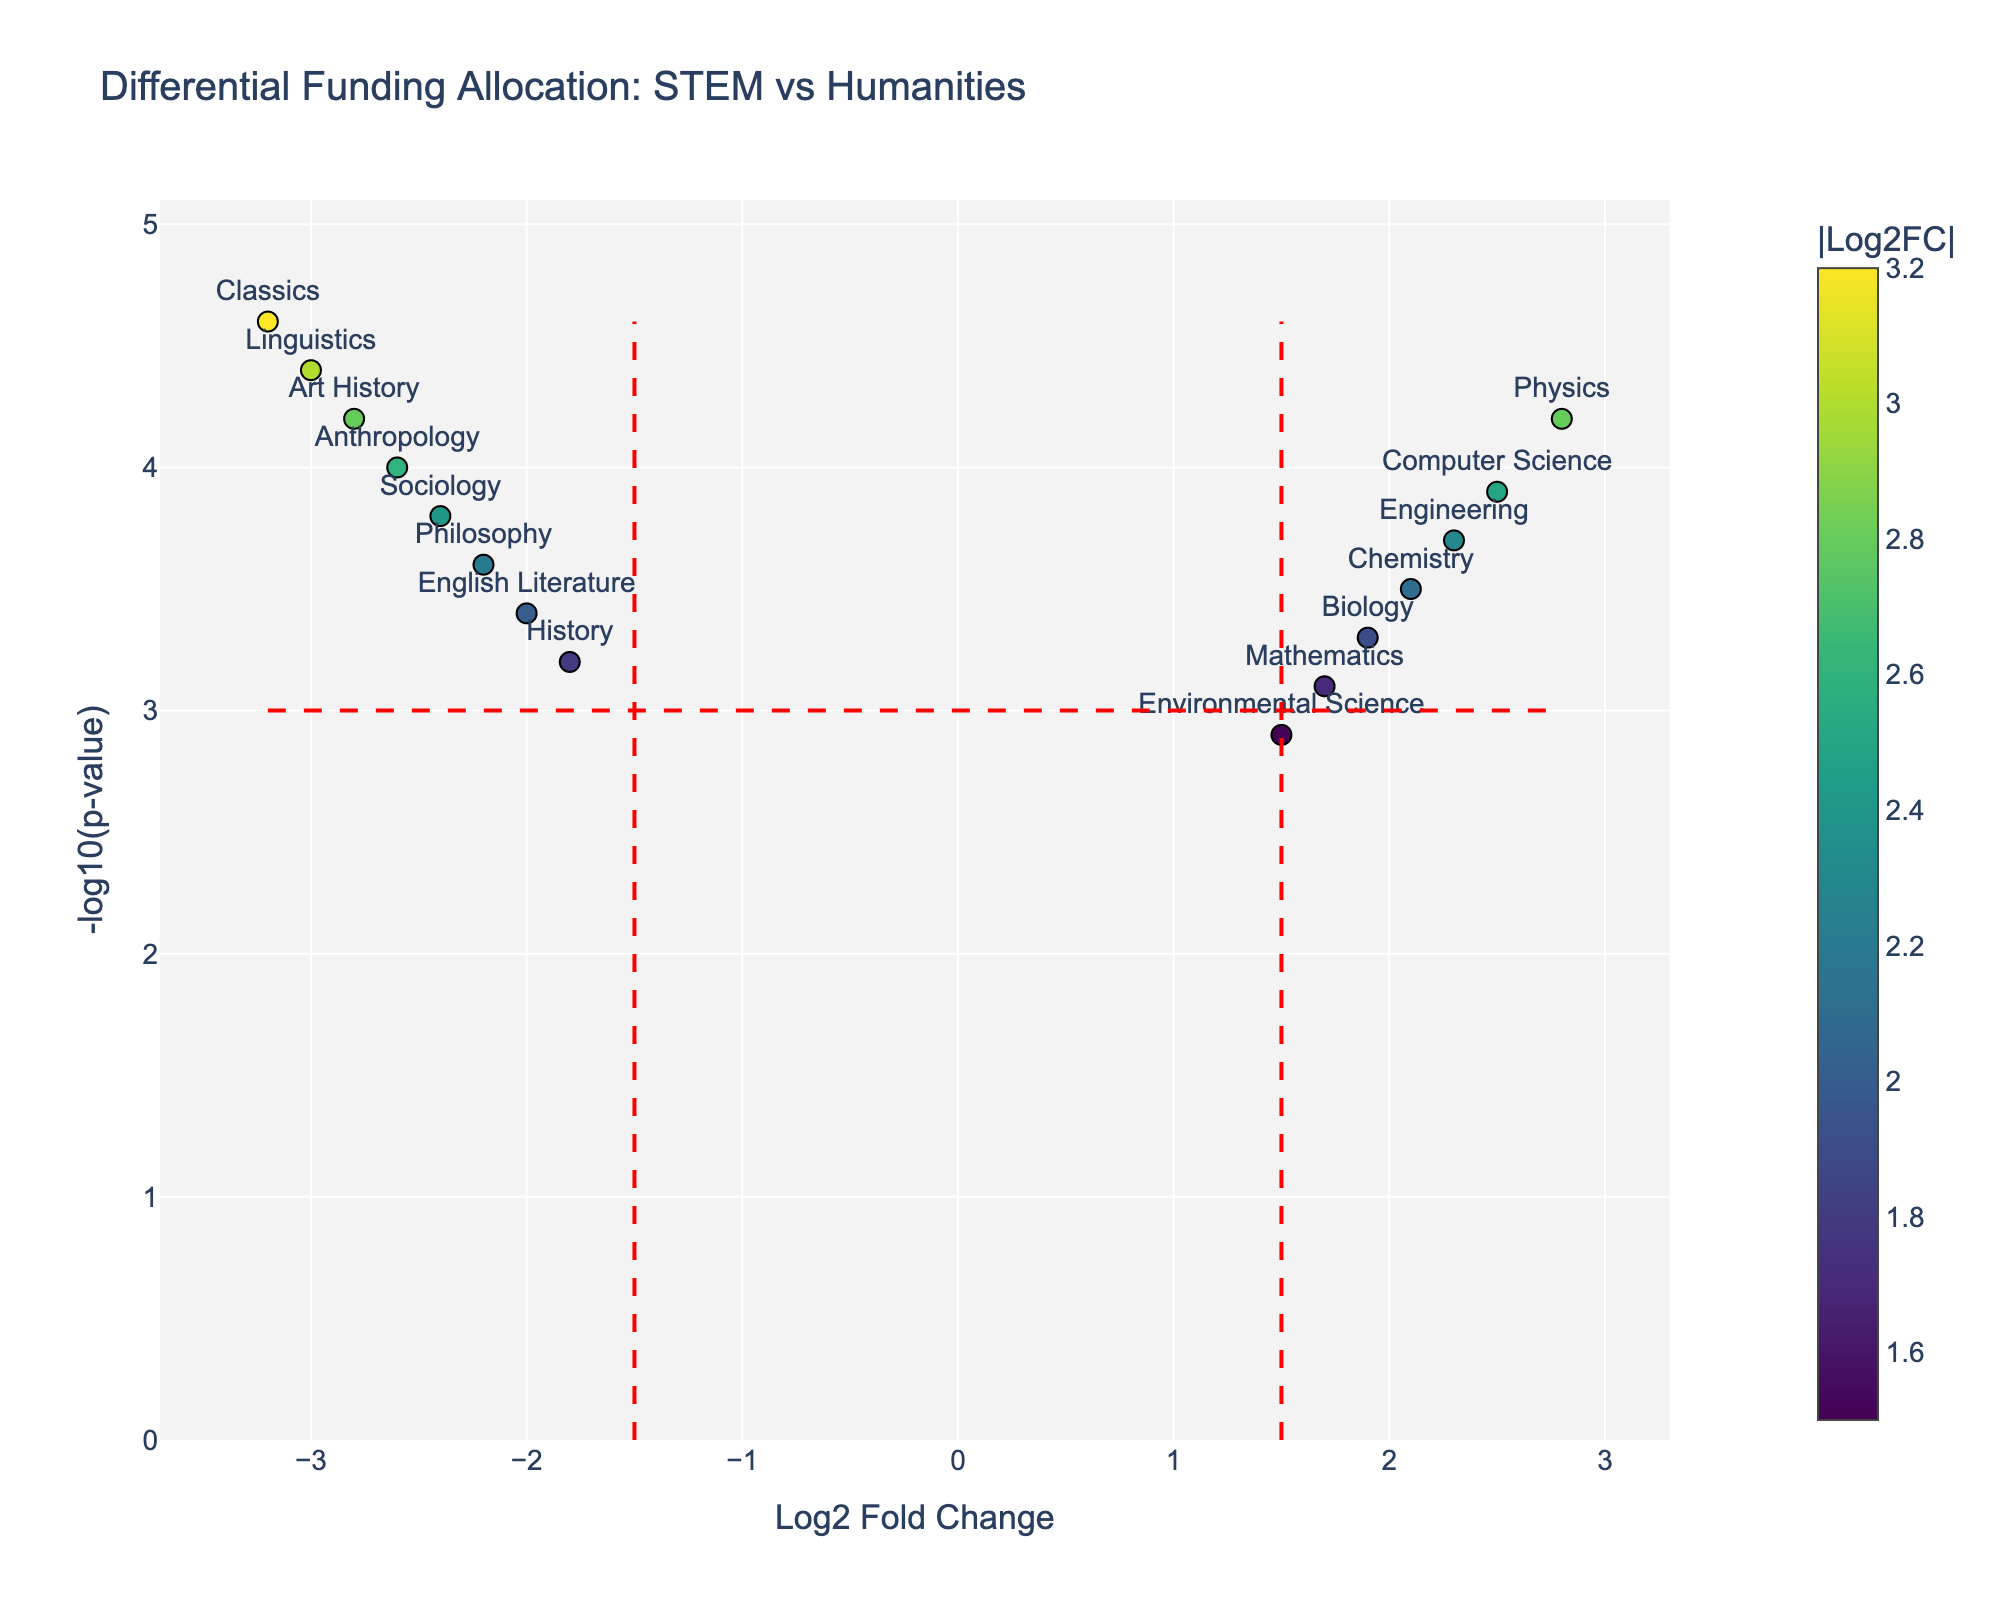How many departments fall under the criteria of high differential funding allocation for STEM? By looking at the figure, we can identify that departments in the upper right quadrant of the volcano plot, where the Log2 Fold Change is greater than 1.5, indicate a high differential funding allocation for STEM. The departments are Physics, Computer Science, Engineering, Chemistry, Biology, and Mathematics.
Answer: 6 Which department has the most significant negative fold change in funding allocation? By examining the plot, the department with the most significant negative Log2 Fold Change is Classics, as it has the lowest value on the x-axis among the negatively skewed departments.
Answer: Classics What is the title given to the plot? By reading the text at the top of the plot, we can identify the title. It is clearly mentioned and helps provide context to the data shown.
Answer: Differential Funding Allocation: STEM vs Humanities What thresholds are indicated for statistical significance and log fold change? The volcano plot shows vertical dashed red lines at positive and negative 1.5 in the Log2 Fold Change axis and a horizontal dashed red line at 3.0 in the -log10(p-value) axis, indicating thresholds for significance.
Answer: 1.5 for Log2 Fold Change, 3.0 for -log10(p-value) Which departments have funding allocation patterns above the significance threshold (-log10(p-value) > 3.0)? By examining the y-axis and looking for all data points above the horizontal dashed red line (3.0), we can list the departments having significant patterns. They are Physics, Computer Science, Engineering, Chemistry, Biology, Mathematics, Environmental Science, History, English Literature, Philosophy, Sociology, Anthropology, Art History, Linguistics, and Classics.
Answer: 14 departments Are there more STEM or humanities departments with significant differential funding allocation? We count the count the significant STEM (6) and humanities (8) departments above the significance threshold (-log10(p-value) > 3.0).
Answer: humanities Which department has the highest value in terms of -log10(p-value)? We look at the highest point on the y-axis to find the department with the highest value. This department's label can be directly read off the plot.
Answer: Classics What is the log2 fold change for Linguistics? By looking at the plot, we find the point labeled "Linguistics" and check its horizontal position on the x-axis to determine the log2 fold change value.
Answer: -3.0 Which has a higher fold change, Biology or Sociology? We compare the x-axis positions for Biology and Sociology. Biology is further to the right, indicating a higher Log2 Fold Change.
Answer: Biology 